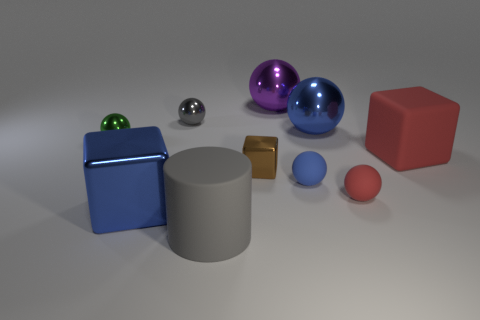Subtract all gray cylinders. How many blue spheres are left? 2 Subtract all big blocks. How many blocks are left? 1 Subtract 1 blocks. How many blocks are left? 2 Subtract all blue spheres. How many spheres are left? 4 Subtract all yellow spheres. Subtract all brown blocks. How many spheres are left? 6 Subtract all cylinders. How many objects are left? 9 Subtract all blue metallic objects. Subtract all tiny balls. How many objects are left? 4 Add 5 large rubber things. How many large rubber things are left? 7 Add 10 big cyan metallic blocks. How many big cyan metallic blocks exist? 10 Subtract 0 red cylinders. How many objects are left? 10 